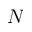<formula> <loc_0><loc_0><loc_500><loc_500>N</formula> 